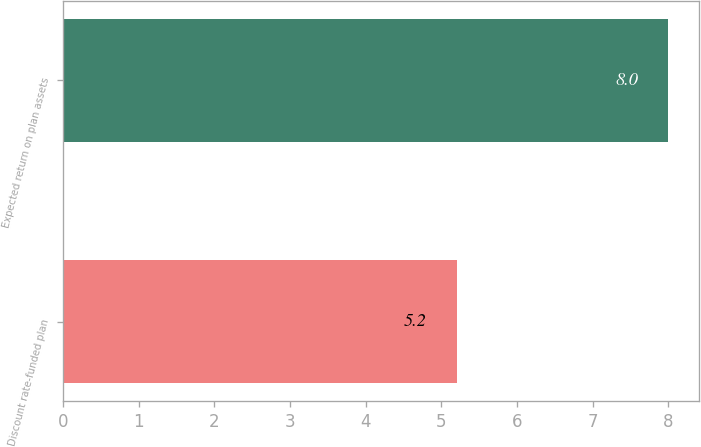Convert chart. <chart><loc_0><loc_0><loc_500><loc_500><bar_chart><fcel>Discount rate-funded plan<fcel>Expected return on plan assets<nl><fcel>5.2<fcel>8<nl></chart> 